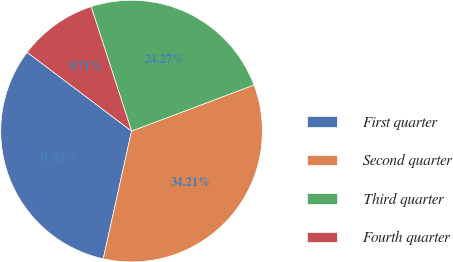<chart> <loc_0><loc_0><loc_500><loc_500><pie_chart><fcel>First quarter<fcel>Second quarter<fcel>Third quarter<fcel>Fourth quarter<nl><fcel>31.82%<fcel>34.21%<fcel>24.27%<fcel>9.71%<nl></chart> 